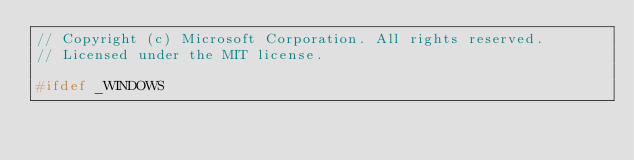Convert code to text. <code><loc_0><loc_0><loc_500><loc_500><_C++_>// Copyright (c) Microsoft Corporation. All rights reserved.
// Licensed under the MIT license.

#ifdef _WINDOWS</code> 